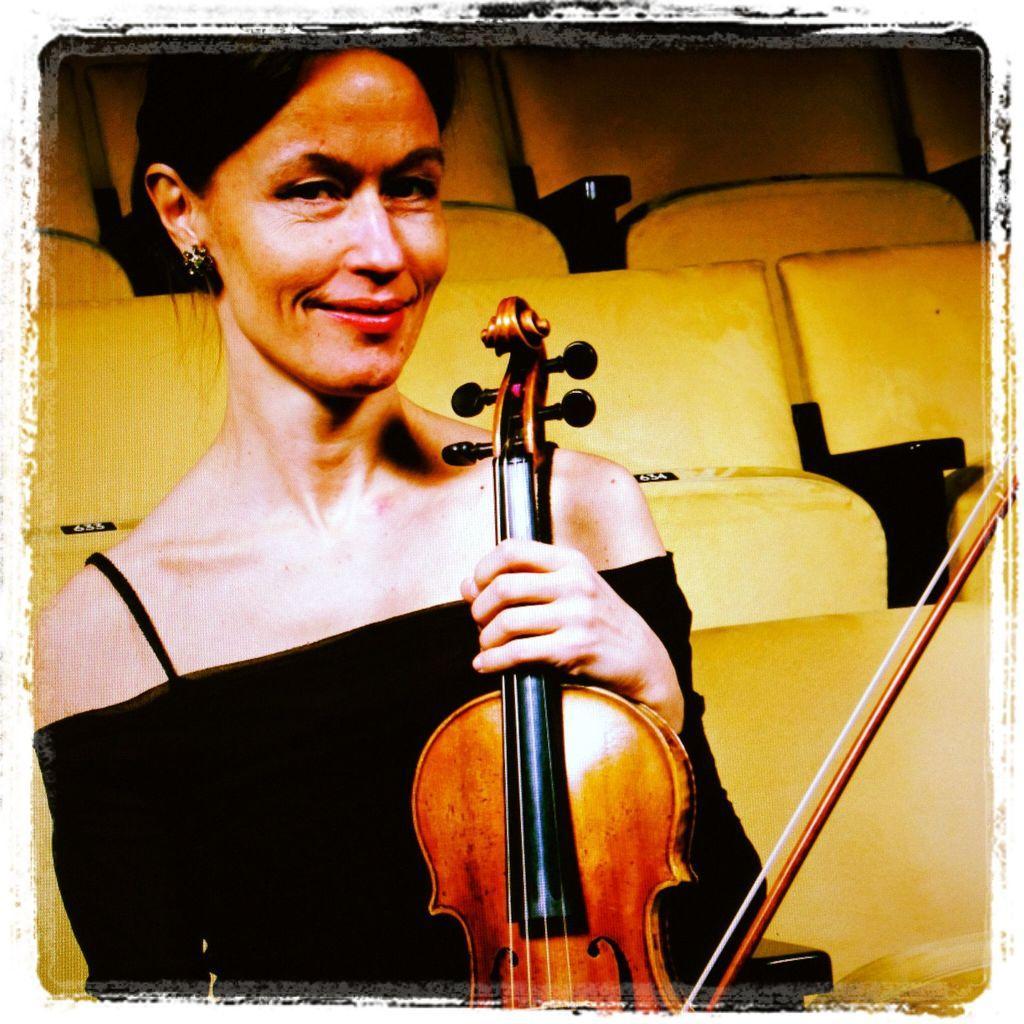Describe this image in one or two sentences. In this picture we have a woman sitting in the chair by catching the violin in her hand. 